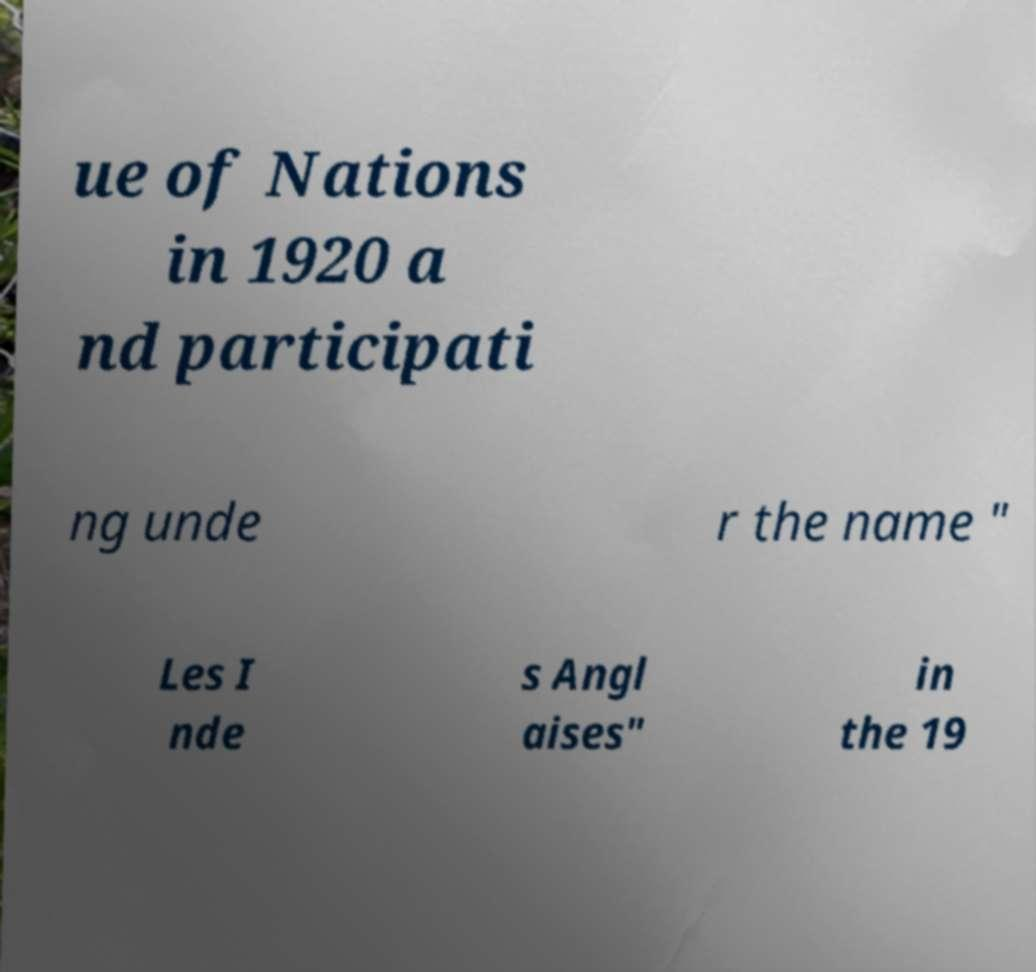What messages or text are displayed in this image? I need them in a readable, typed format. ue of Nations in 1920 a nd participati ng unde r the name " Les I nde s Angl aises" in the 19 